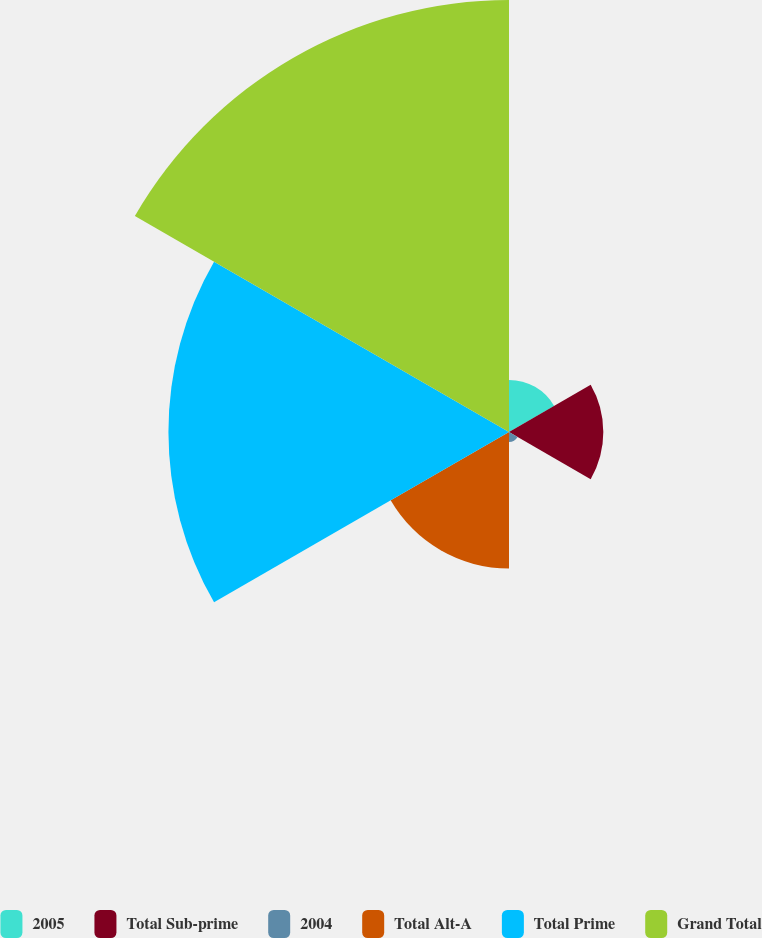<chart> <loc_0><loc_0><loc_500><loc_500><pie_chart><fcel>2005<fcel>Total Sub-prime<fcel>2004<fcel>Total Alt-A<fcel>Total Prime<fcel>Grand Total<nl><fcel>4.89%<fcel>8.85%<fcel>0.93%<fcel>12.82%<fcel>31.96%<fcel>40.54%<nl></chart> 